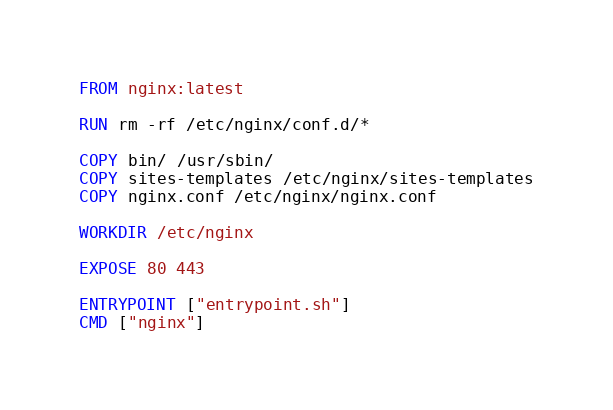<code> <loc_0><loc_0><loc_500><loc_500><_Dockerfile_>FROM nginx:latest

RUN rm -rf /etc/nginx/conf.d/*

COPY bin/ /usr/sbin/
COPY sites-templates /etc/nginx/sites-templates
COPY nginx.conf /etc/nginx/nginx.conf

WORKDIR /etc/nginx

EXPOSE 80 443

ENTRYPOINT ["entrypoint.sh"]
CMD ["nginx"]
</code> 